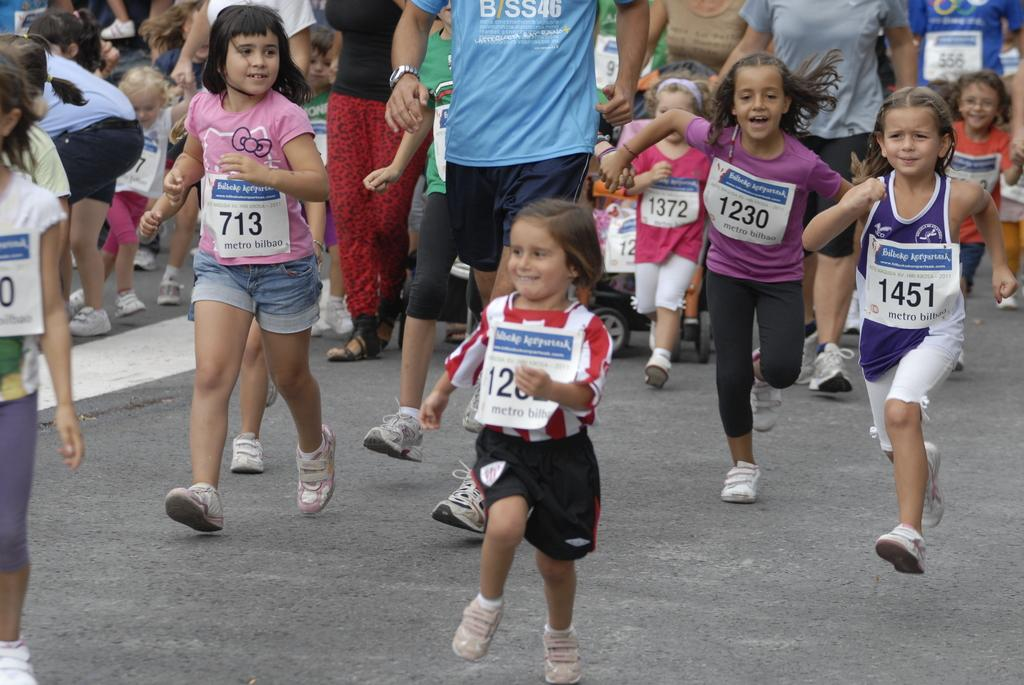<image>
Offer a succinct explanation of the picture presented. A group of children are running a marathon with signs that have numbers including 1451. 